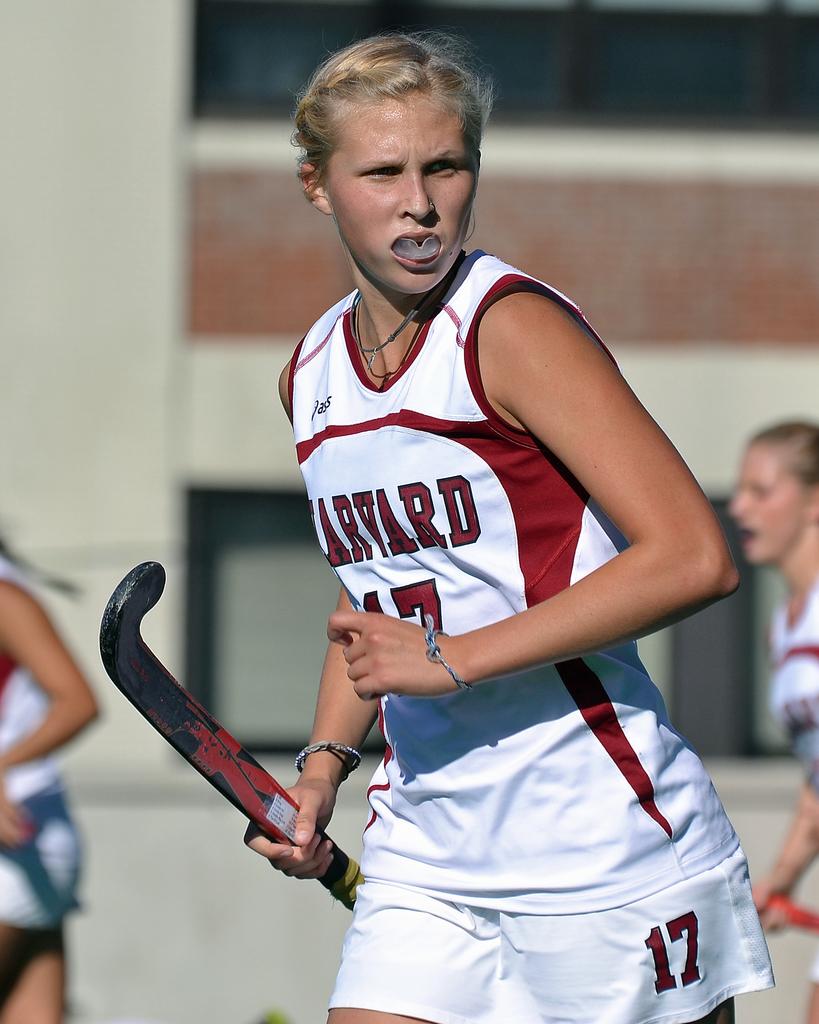What team does the player play for?
Your response must be concise. Harvard. What number is on the woman's shorts?
Give a very brief answer. 17. 